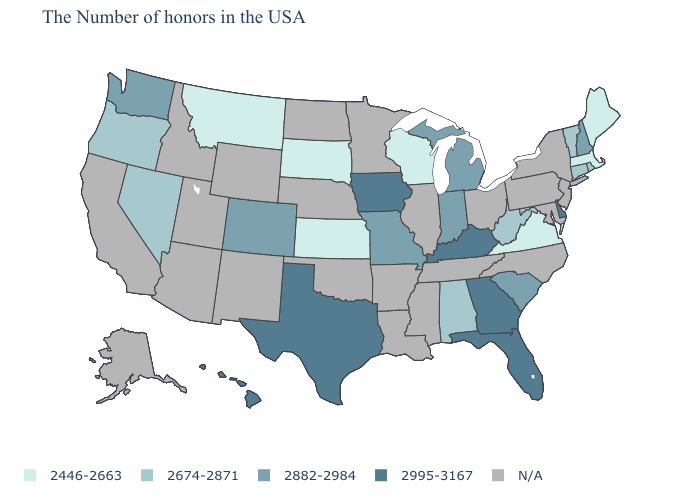Does Connecticut have the highest value in the Northeast?
Be succinct. No. Name the states that have a value in the range 2995-3167?
Give a very brief answer. Delaware, Florida, Georgia, Kentucky, Iowa, Texas, Hawaii. What is the value of North Dakota?
Keep it brief. N/A. What is the value of New York?
Keep it brief. N/A. What is the highest value in states that border Massachusetts?
Write a very short answer. 2882-2984. Does Indiana have the highest value in the MidWest?
Write a very short answer. No. Does Iowa have the highest value in the MidWest?
Keep it brief. Yes. What is the highest value in the USA?
Answer briefly. 2995-3167. Does Colorado have the highest value in the West?
Quick response, please. No. What is the highest value in states that border California?
Write a very short answer. 2674-2871. Name the states that have a value in the range 2995-3167?
Give a very brief answer. Delaware, Florida, Georgia, Kentucky, Iowa, Texas, Hawaii. Which states hav the highest value in the Northeast?
Be succinct. New Hampshire. What is the value of Ohio?
Give a very brief answer. N/A. How many symbols are there in the legend?
Be succinct. 5. Among the states that border Georgia , which have the lowest value?
Short answer required. Alabama. 